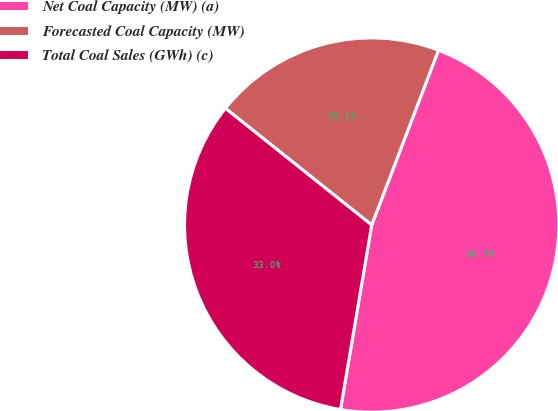Convert chart to OTSL. <chart><loc_0><loc_0><loc_500><loc_500><pie_chart><fcel>Net Coal Capacity (MW) (a)<fcel>Forecasted Coal Capacity (MW)<fcel>Total Coal Sales (GWh) (c)<nl><fcel>46.86%<fcel>20.09%<fcel>33.05%<nl></chart> 